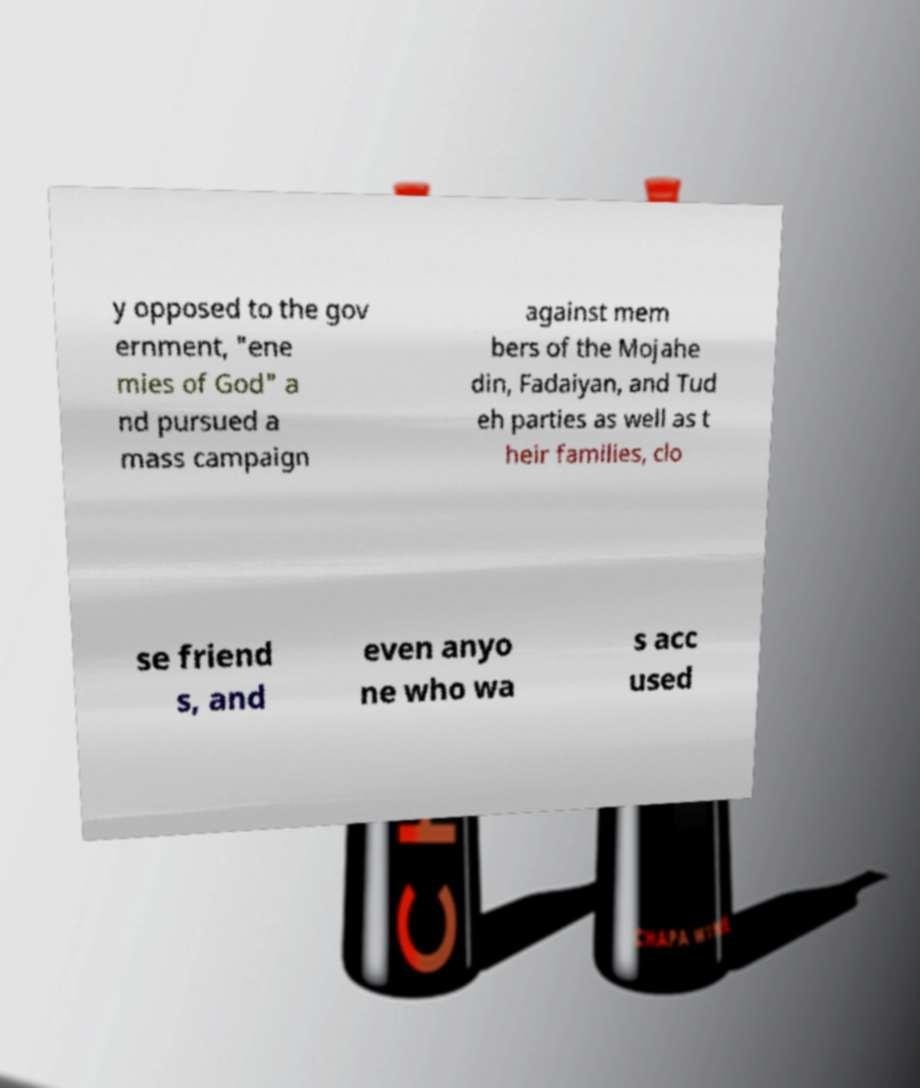For documentation purposes, I need the text within this image transcribed. Could you provide that? y opposed to the gov ernment, "ene mies of God" a nd pursued a mass campaign against mem bers of the Mojahe din, Fadaiyan, and Tud eh parties as well as t heir families, clo se friend s, and even anyo ne who wa s acc used 